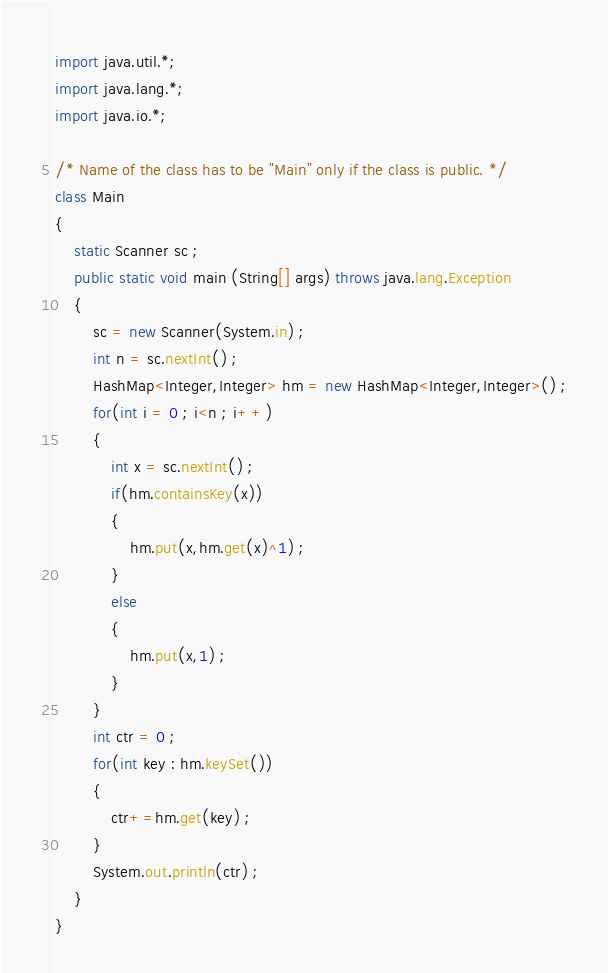<code> <loc_0><loc_0><loc_500><loc_500><_Java_>import java.util.*;
import java.lang.*;
import java.io.*;
 
/* Name of the class has to be "Main" only if the class is public. */
class Main
{
    static Scanner sc ;
	public static void main (String[] args) throws java.lang.Exception
	{
	    sc = new Scanner(System.in) ;
	    int n = sc.nextInt() ;
	    HashMap<Integer,Integer> hm = new HashMap<Integer,Integer>() ;
	    for(int i = 0 ; i<n ; i++)
	    {
	        int x = sc.nextInt() ;
	        if(hm.containsKey(x))
	        {
	            hm.put(x,hm.get(x)^1) ;
	        }
	        else
	        {
	            hm.put(x,1) ;    
	        }
	    }
	    int ctr = 0 ;
	    for(int key : hm.keySet())
	    {
	        ctr+=hm.get(key) ;
	    }
	    System.out.println(ctr) ;
	}
}</code> 